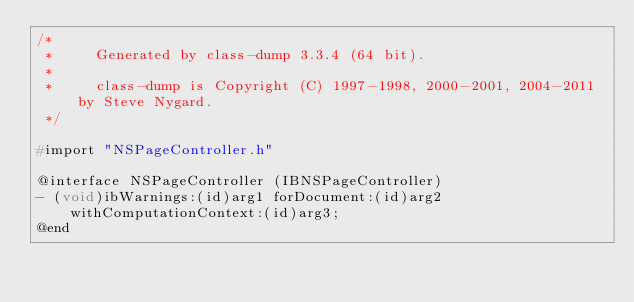Convert code to text. <code><loc_0><loc_0><loc_500><loc_500><_C_>/*
 *     Generated by class-dump 3.3.4 (64 bit).
 *
 *     class-dump is Copyright (C) 1997-1998, 2000-2001, 2004-2011 by Steve Nygard.
 */

#import "NSPageController.h"

@interface NSPageController (IBNSPageController)
- (void)ibWarnings:(id)arg1 forDocument:(id)arg2 withComputationContext:(id)arg3;
@end

</code> 